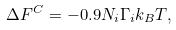Convert formula to latex. <formula><loc_0><loc_0><loc_500><loc_500>\Delta F ^ { C } = - 0 . 9 N _ { i } \Gamma _ { i } k _ { B } T ,</formula> 